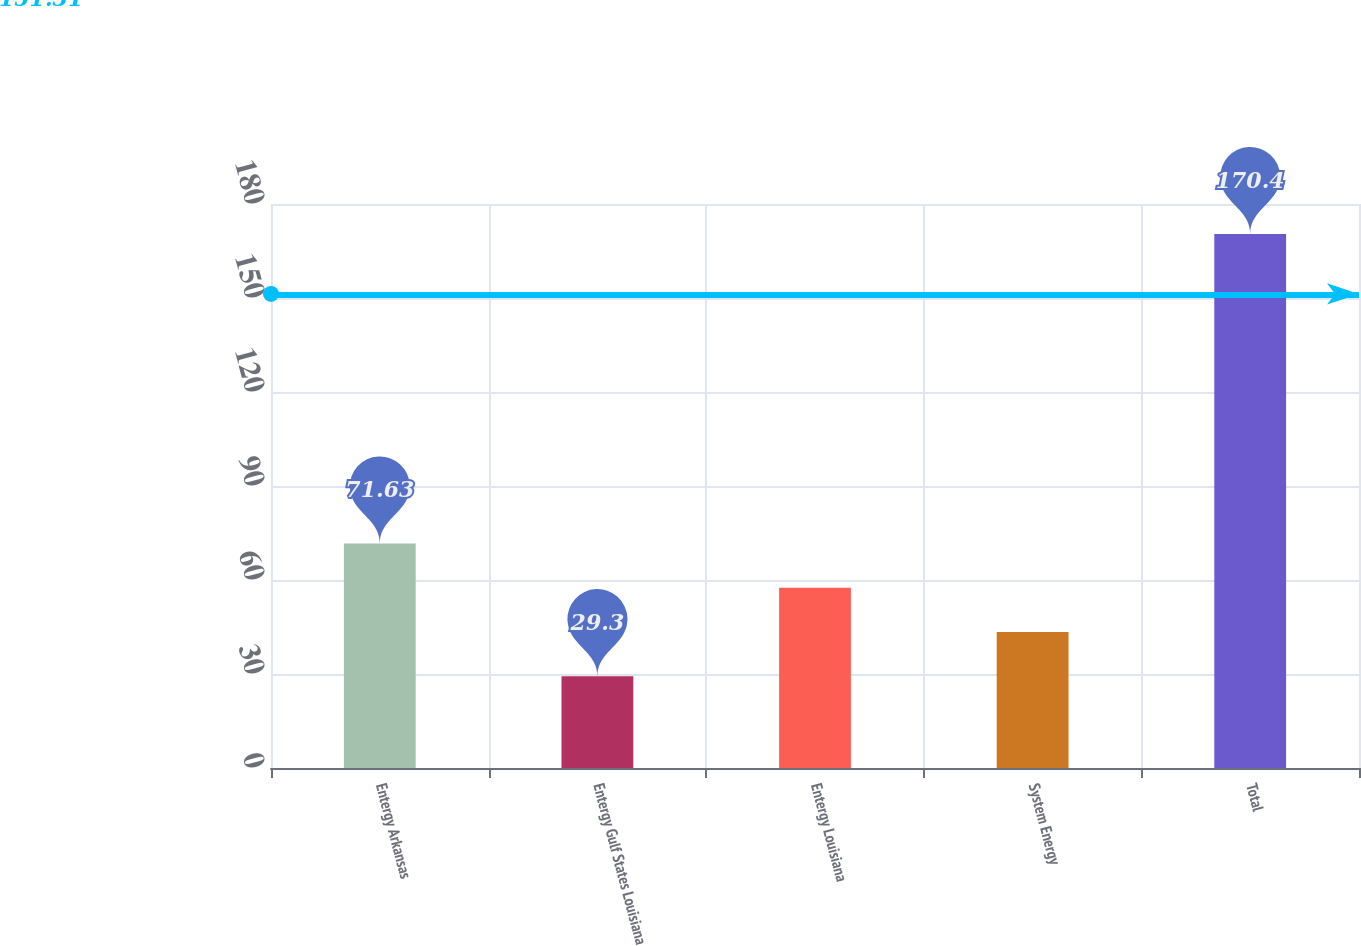Convert chart to OTSL. <chart><loc_0><loc_0><loc_500><loc_500><bar_chart><fcel>Entergy Arkansas<fcel>Entergy Gulf States Louisiana<fcel>Entergy Louisiana<fcel>System Energy<fcel>Total<nl><fcel>71.63<fcel>29.3<fcel>57.52<fcel>43.41<fcel>170.4<nl></chart> 